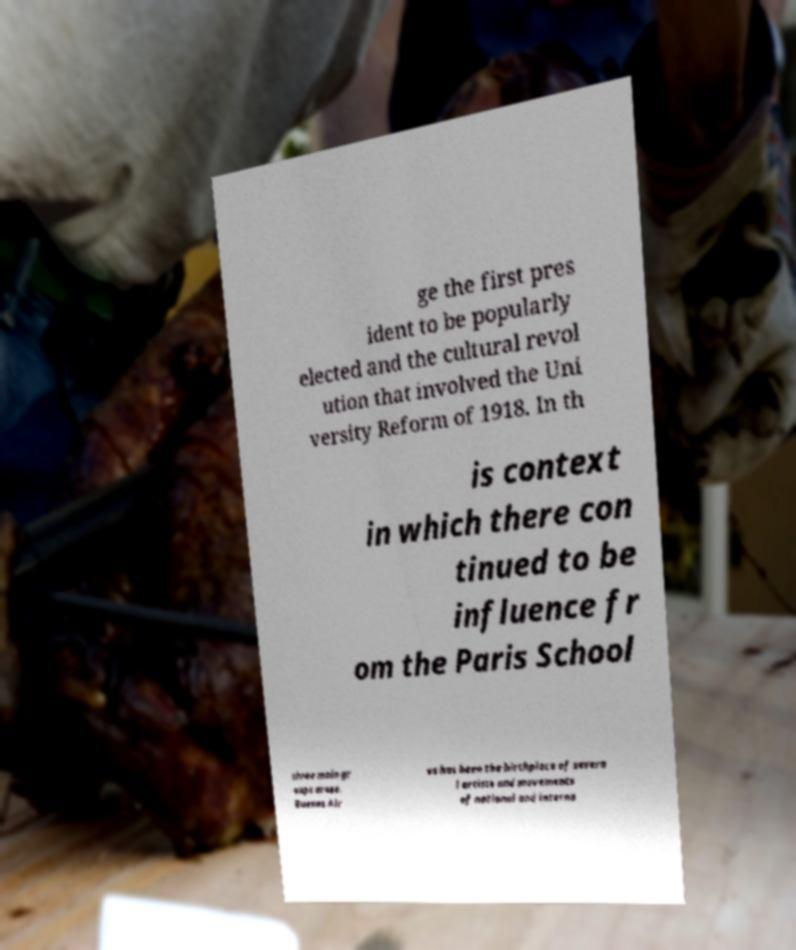What messages or text are displayed in this image? I need them in a readable, typed format. ge the first pres ident to be popularly elected and the cultural revol ution that involved the Uni versity Reform of 1918. In th is context in which there con tinued to be influence fr om the Paris School three main gr oups arose. Buenos Air es has been the birthplace of severa l artists and movements of national and interna 